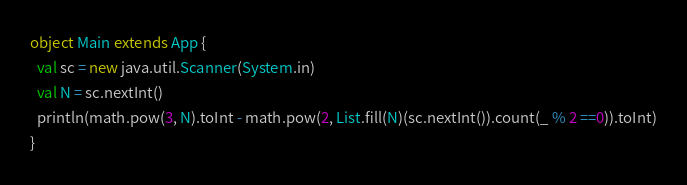Convert code to text. <code><loc_0><loc_0><loc_500><loc_500><_Scala_>object Main extends App {
  val sc = new java.util.Scanner(System.in)
  val N = sc.nextInt()
  println(math.pow(3, N).toInt - math.pow(2, List.fill(N)(sc.nextInt()).count(_ % 2 ==0)).toInt)
}
</code> 